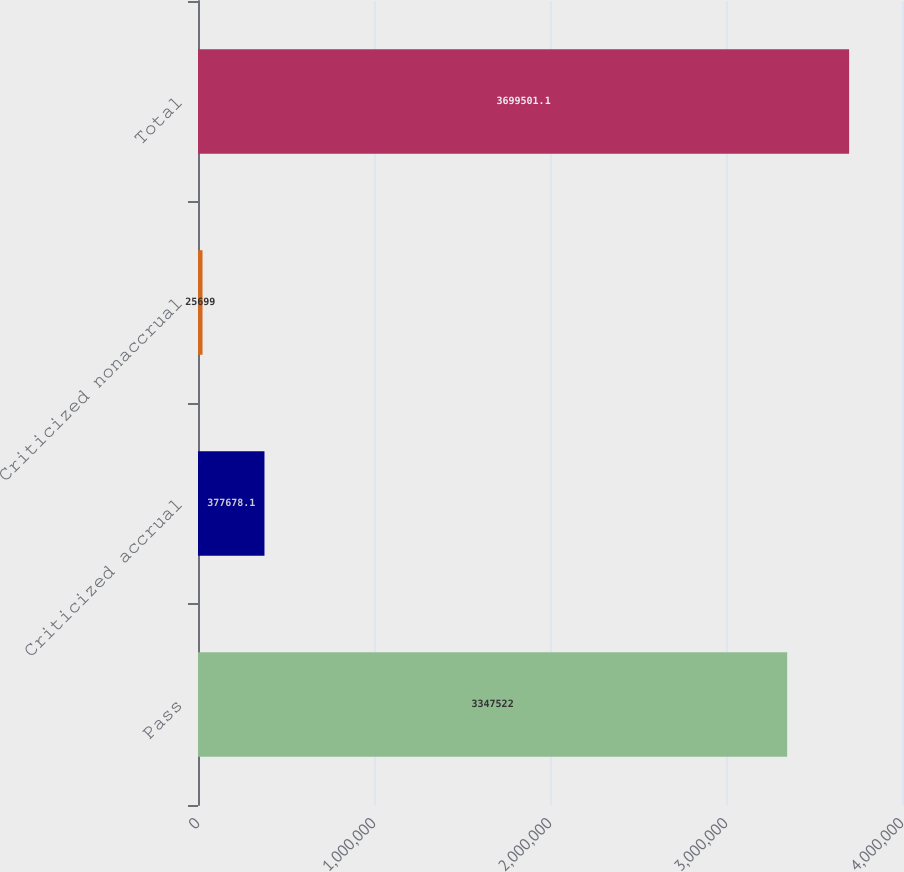Convert chart. <chart><loc_0><loc_0><loc_500><loc_500><bar_chart><fcel>Pass<fcel>Criticized accrual<fcel>Criticized nonaccrual<fcel>Total<nl><fcel>3.34752e+06<fcel>377678<fcel>25699<fcel>3.6995e+06<nl></chart> 